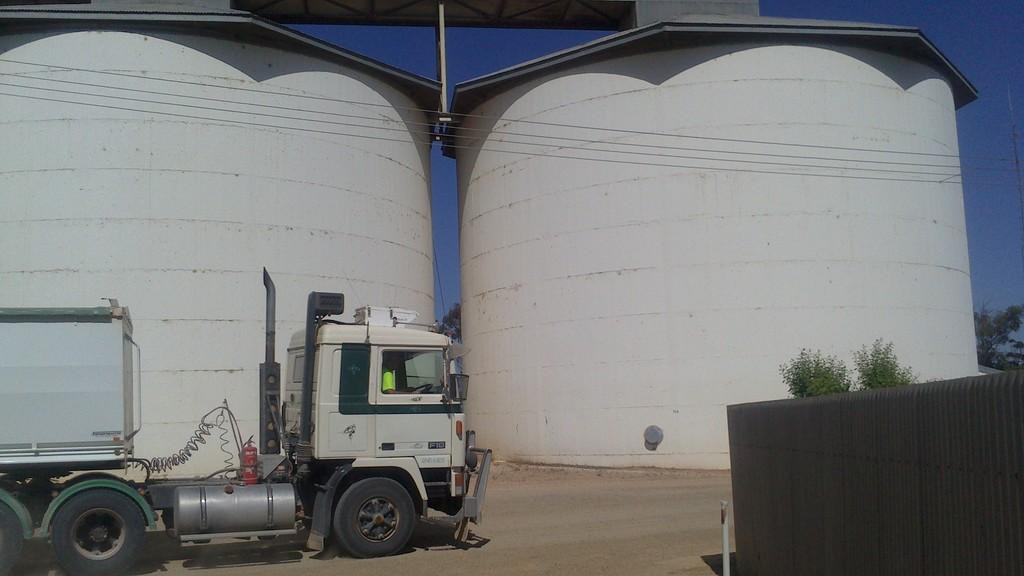How many tanks are visible in the image? There are two tanks in the image. What is located in front of one of the tanks? There is a vehicle in front of one of the tanks. What is located in front of the second tank? There are plants in front of the second tank. What type of brass material is used to construct the tanks in the image? The tanks in the image are not made of brass; they are likely made of metal or other materials used for constructing tanks. 